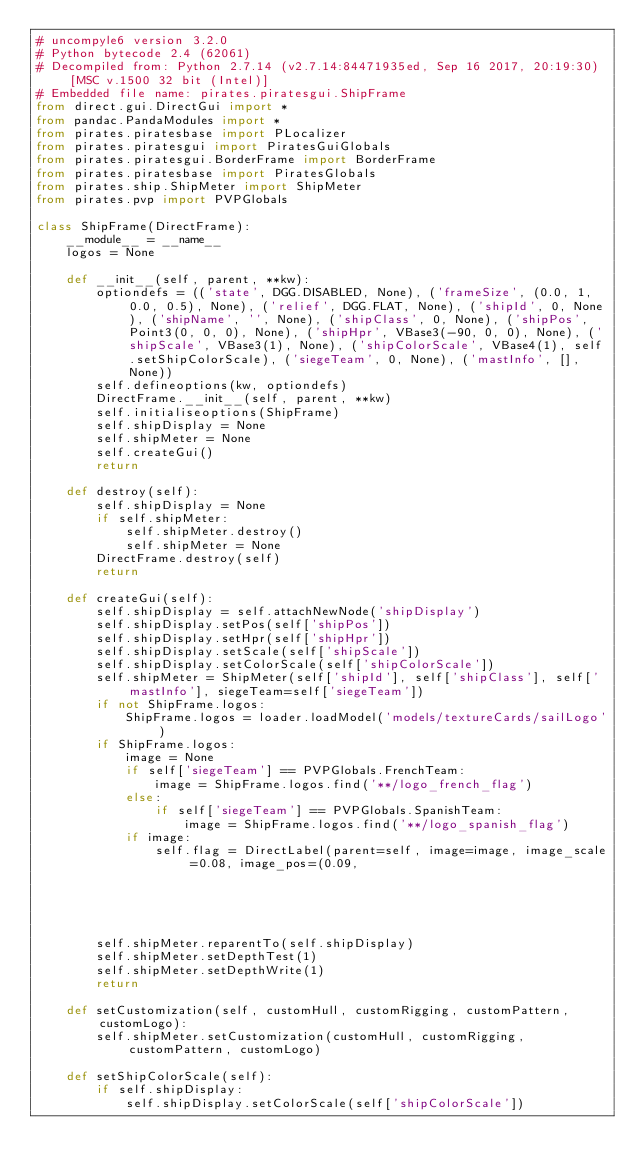<code> <loc_0><loc_0><loc_500><loc_500><_Python_># uncompyle6 version 3.2.0
# Python bytecode 2.4 (62061)
# Decompiled from: Python 2.7.14 (v2.7.14:84471935ed, Sep 16 2017, 20:19:30) [MSC v.1500 32 bit (Intel)]
# Embedded file name: pirates.piratesgui.ShipFrame
from direct.gui.DirectGui import *
from pandac.PandaModules import *
from pirates.piratesbase import PLocalizer
from pirates.piratesgui import PiratesGuiGlobals
from pirates.piratesgui.BorderFrame import BorderFrame
from pirates.piratesbase import PiratesGlobals
from pirates.ship.ShipMeter import ShipMeter
from pirates.pvp import PVPGlobals

class ShipFrame(DirectFrame):
    __module__ = __name__
    logos = None

    def __init__(self, parent, **kw):
        optiondefs = (('state', DGG.DISABLED, None), ('frameSize', (0.0, 1, 0.0, 0.5), None), ('relief', DGG.FLAT, None), ('shipId', 0, None), ('shipName', '', None), ('shipClass', 0, None), ('shipPos', Point3(0, 0, 0), None), ('shipHpr', VBase3(-90, 0, 0), None), ('shipScale', VBase3(1), None), ('shipColorScale', VBase4(1), self.setShipColorScale), ('siegeTeam', 0, None), ('mastInfo', [], None))
        self.defineoptions(kw, optiondefs)
        DirectFrame.__init__(self, parent, **kw)
        self.initialiseoptions(ShipFrame)
        self.shipDisplay = None
        self.shipMeter = None
        self.createGui()
        return

    def destroy(self):
        self.shipDisplay = None
        if self.shipMeter:
            self.shipMeter.destroy()
            self.shipMeter = None
        DirectFrame.destroy(self)
        return

    def createGui(self):
        self.shipDisplay = self.attachNewNode('shipDisplay')
        self.shipDisplay.setPos(self['shipPos'])
        self.shipDisplay.setHpr(self['shipHpr'])
        self.shipDisplay.setScale(self['shipScale'])
        self.shipDisplay.setColorScale(self['shipColorScale'])
        self.shipMeter = ShipMeter(self['shipId'], self['shipClass'], self['mastInfo'], siegeTeam=self['siegeTeam'])
        if not ShipFrame.logos:
            ShipFrame.logos = loader.loadModel('models/textureCards/sailLogo')
        if ShipFrame.logos:
            image = None
            if self['siegeTeam'] == PVPGlobals.FrenchTeam:
                image = ShipFrame.logos.find('**/logo_french_flag')
            else:
                if self['siegeTeam'] == PVPGlobals.SpanishTeam:
                    image = ShipFrame.logos.find('**/logo_spanish_flag')
            if image:
                self.flag = DirectLabel(parent=self, image=image, image_scale=0.08, image_pos=(0.09,
                                                                                               0,
                                                                                               0.09))
        self.shipMeter.reparentTo(self.shipDisplay)
        self.shipMeter.setDepthTest(1)
        self.shipMeter.setDepthWrite(1)
        return

    def setCustomization(self, customHull, customRigging, customPattern, customLogo):
        self.shipMeter.setCustomization(customHull, customRigging, customPattern, customLogo)

    def setShipColorScale(self):
        if self.shipDisplay:
            self.shipDisplay.setColorScale(self['shipColorScale'])</code> 